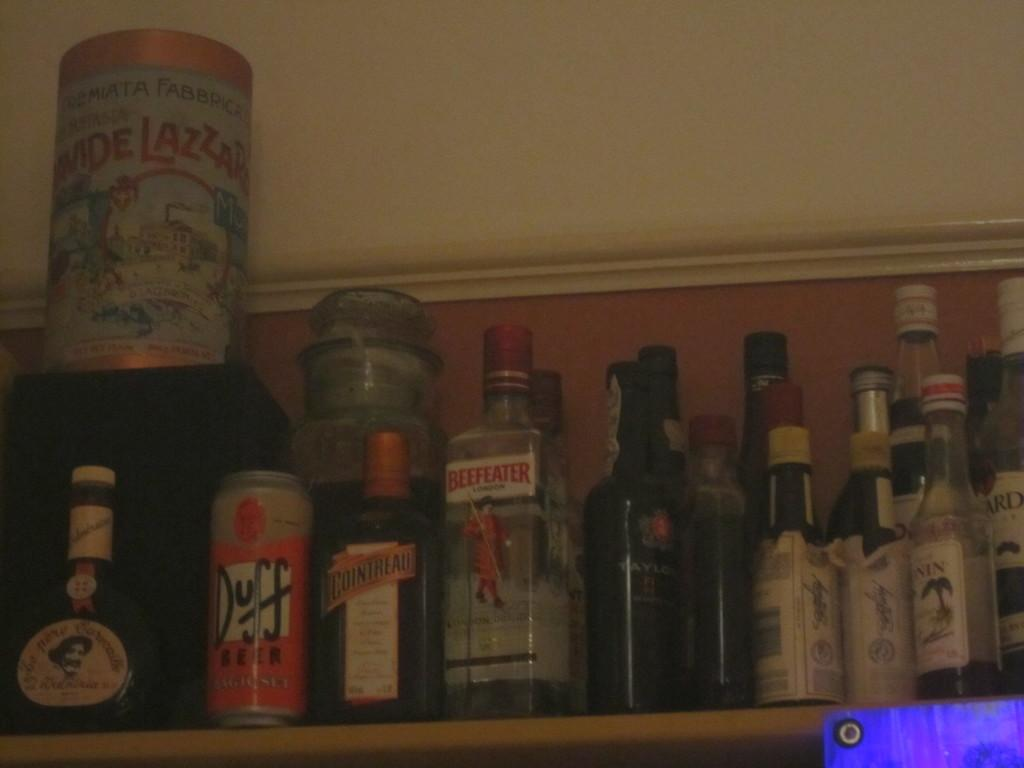<image>
Present a compact description of the photo's key features. bottles of liquor on a shelf including Beefeater 